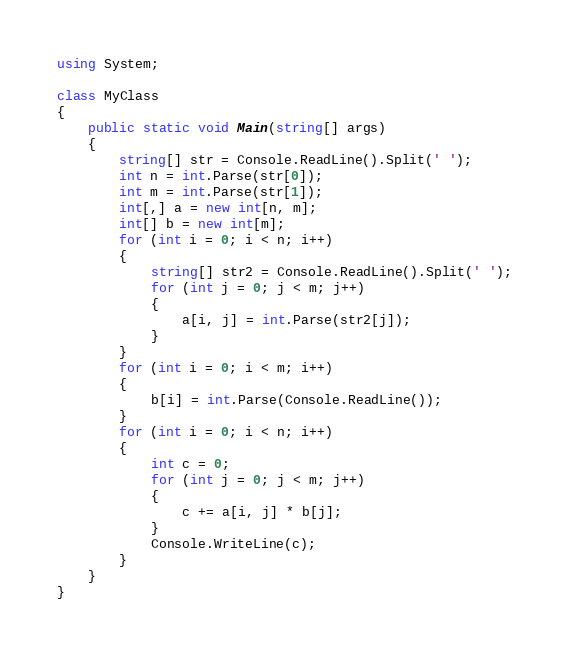Convert code to text. <code><loc_0><loc_0><loc_500><loc_500><_C#_>using System;

class MyClass
{
    public static void Main(string[] args)
    {
        string[] str = Console.ReadLine().Split(' ');
        int n = int.Parse(str[0]);
        int m = int.Parse(str[1]);
        int[,] a = new int[n, m];
        int[] b = new int[m];
        for (int i = 0; i < n; i++)
        {
            string[] str2 = Console.ReadLine().Split(' ');
            for (int j = 0; j < m; j++)
            {
                a[i, j] = int.Parse(str2[j]);
            }
        }
        for (int i = 0; i < m; i++)
        {
            b[i] = int.Parse(Console.ReadLine());
        }
        for (int i = 0; i < n; i++)
        {
            int c = 0;
            for (int j = 0; j < m; j++)
            {
                c += a[i, j] * b[j];
            }
            Console.WriteLine(c);
        }
    }
}
</code> 